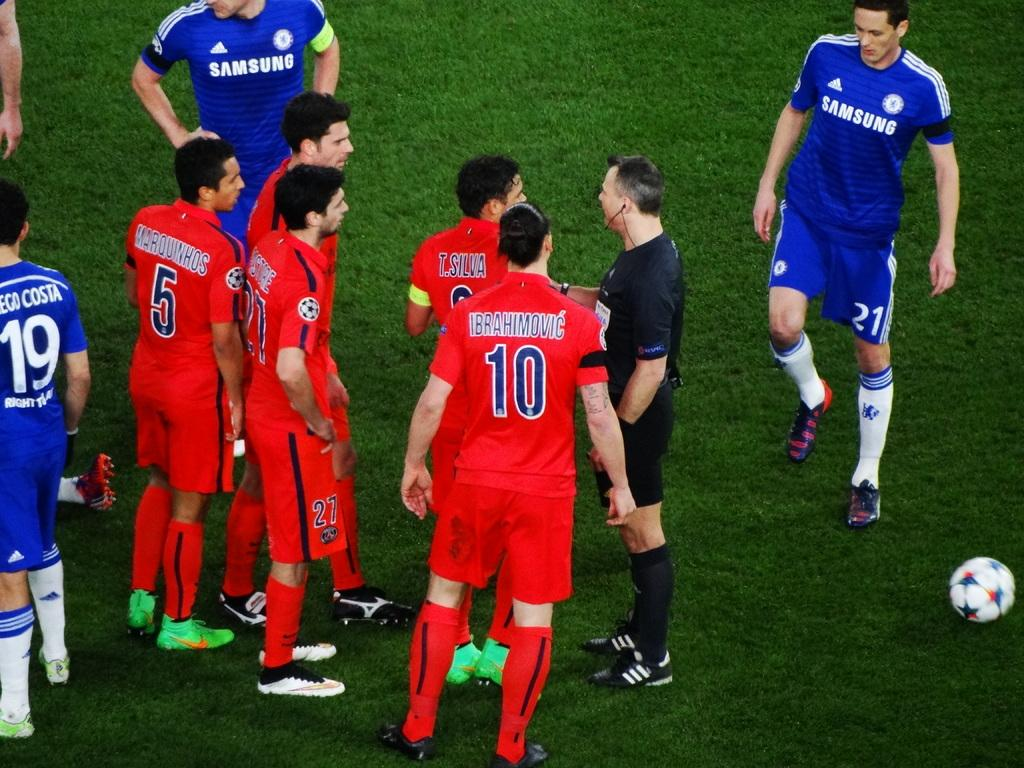How many people are in the image? There is a group of people in the image, but the exact number cannot be determined from the provided facts. What is located on the right side of the image? There is a football on the right side of the image. Is there a volcano erupting in the background of the image? There is no mention of a volcano or any eruption in the provided facts, so we cannot determine if there is a volcano in the image. What type of scarf is being worn by the people in the image? There is no mention of any scarves being worn by the people in the image, so we cannot determine the type of scarf. 